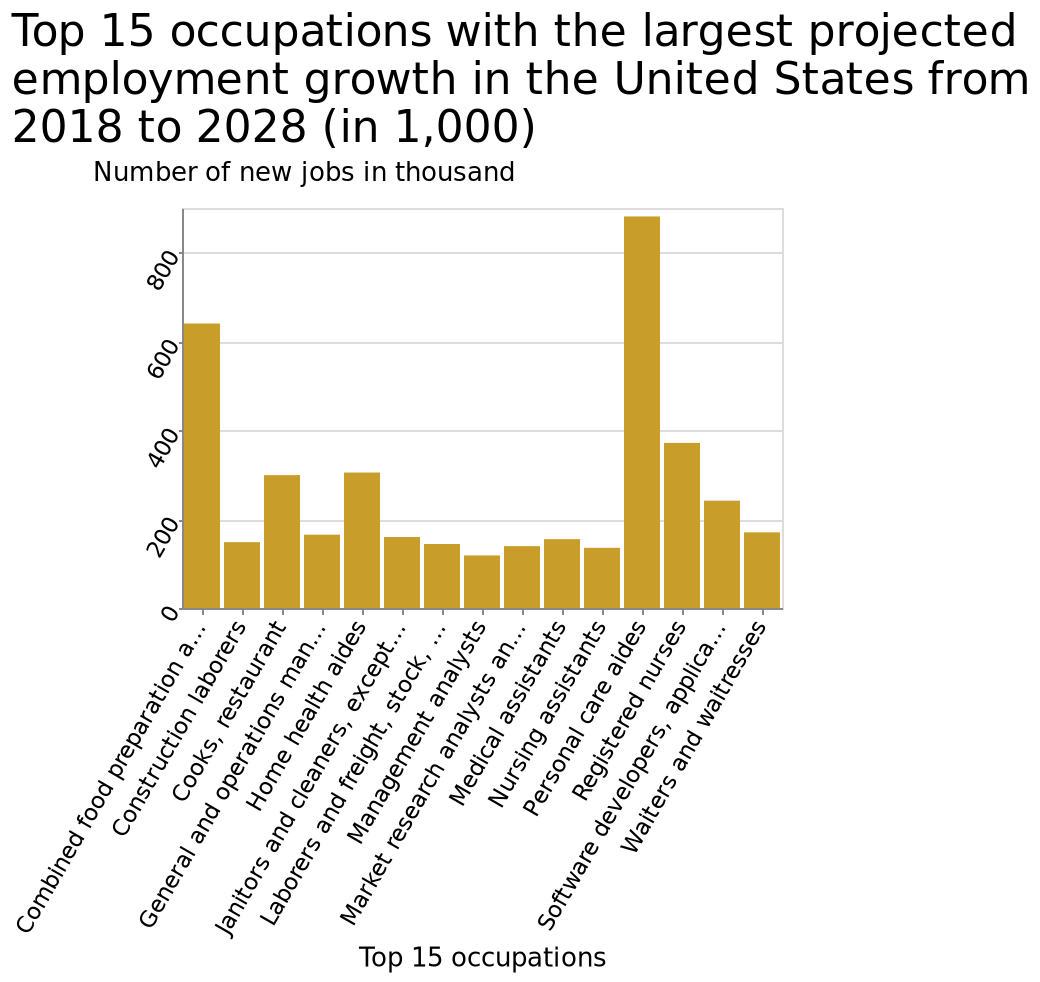<image>
What sector is expected to experience significant employment growth from 2018-2028? The personal care aide sector is expected to experience significant employment growth from 2018-2028. please summary the statistics and relations of the chart It's expected that there will be huge employment growth in the personal care aide sector from 2018-2028. Which occupation is likely to see a boost in employment opportunities? Personal care aides are likely to see a boost in employment opportunities. What is the occupation with the smallest projected employment growth in the United States from 2018 to 2028?  The occupation with the smallest projected employment growth in the United States from 2018 to 2028 is Waiters and waitresses. What is the occupation with the largest projected employment growth in the United States from 2018 to 2028?  The occupation with the largest projected employment growth in the United States from 2018 to 2028 is Combined food preparation and serving workers, including fast food. 